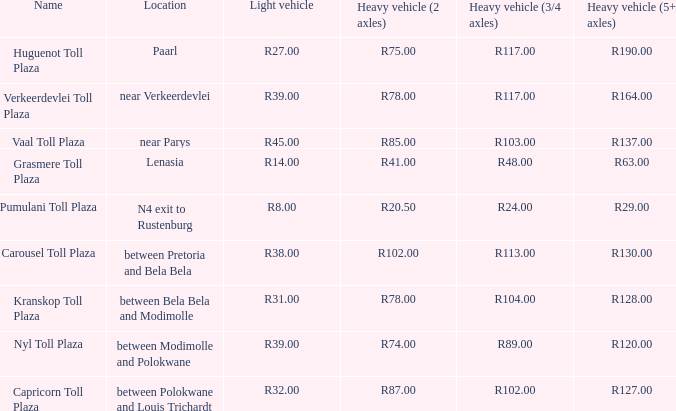What is the location of the Carousel toll plaza? Between pretoria and bela bela. 